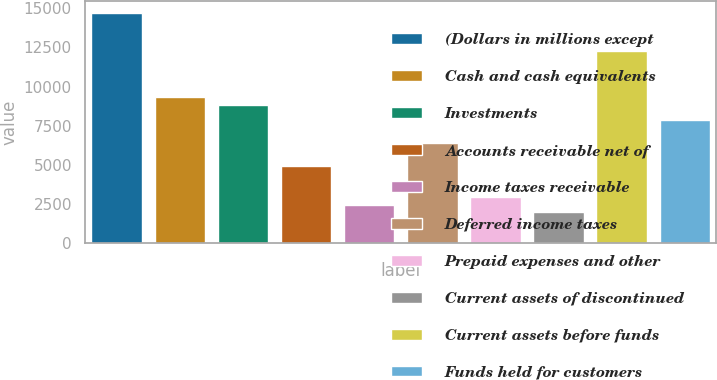<chart> <loc_0><loc_0><loc_500><loc_500><bar_chart><fcel>(Dollars in millions except<fcel>Cash and cash equivalents<fcel>Investments<fcel>Accounts receivable net of<fcel>Income taxes receivable<fcel>Deferred income taxes<fcel>Prepaid expenses and other<fcel>Current assets of discontinued<fcel>Current assets before funds<fcel>Funds held for customers<nl><fcel>14727<fcel>9328.2<fcel>8837.4<fcel>4911<fcel>2457<fcel>6383.4<fcel>2947.8<fcel>1966.2<fcel>12273<fcel>7855.8<nl></chart> 